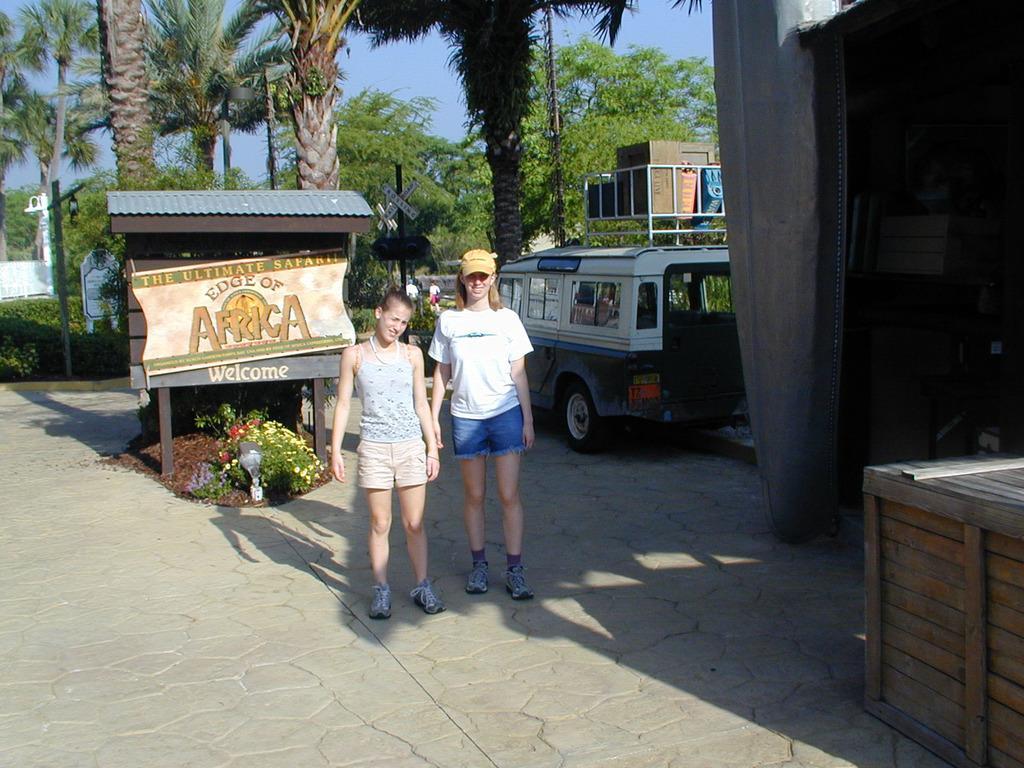Provide a one-sentence caption for the provided image. Kids standing in front of a sign that reads The Ultimate Safari The Edge of Africa. 